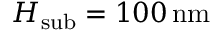<formula> <loc_0><loc_0><loc_500><loc_500>H _ { s u b } = 1 0 0 \, n m</formula> 